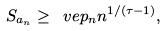Convert formula to latex. <formula><loc_0><loc_0><loc_500><loc_500>S _ { a _ { n } } \geq \ v e p _ { n } n ^ { 1 / ( \tau - 1 ) } ,</formula> 